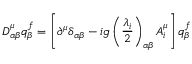Convert formula to latex. <formula><loc_0><loc_0><loc_500><loc_500>D _ { \alpha \beta } ^ { \mu } q _ { \beta } ^ { f } = \left [ \partial ^ { \mu } \delta _ { \alpha \beta } - i g \left ( \frac { \lambda _ { i } } { 2 } \right ) _ { \alpha \beta } A _ { i } ^ { \mu } \right ] q _ { \beta } ^ { f }</formula> 